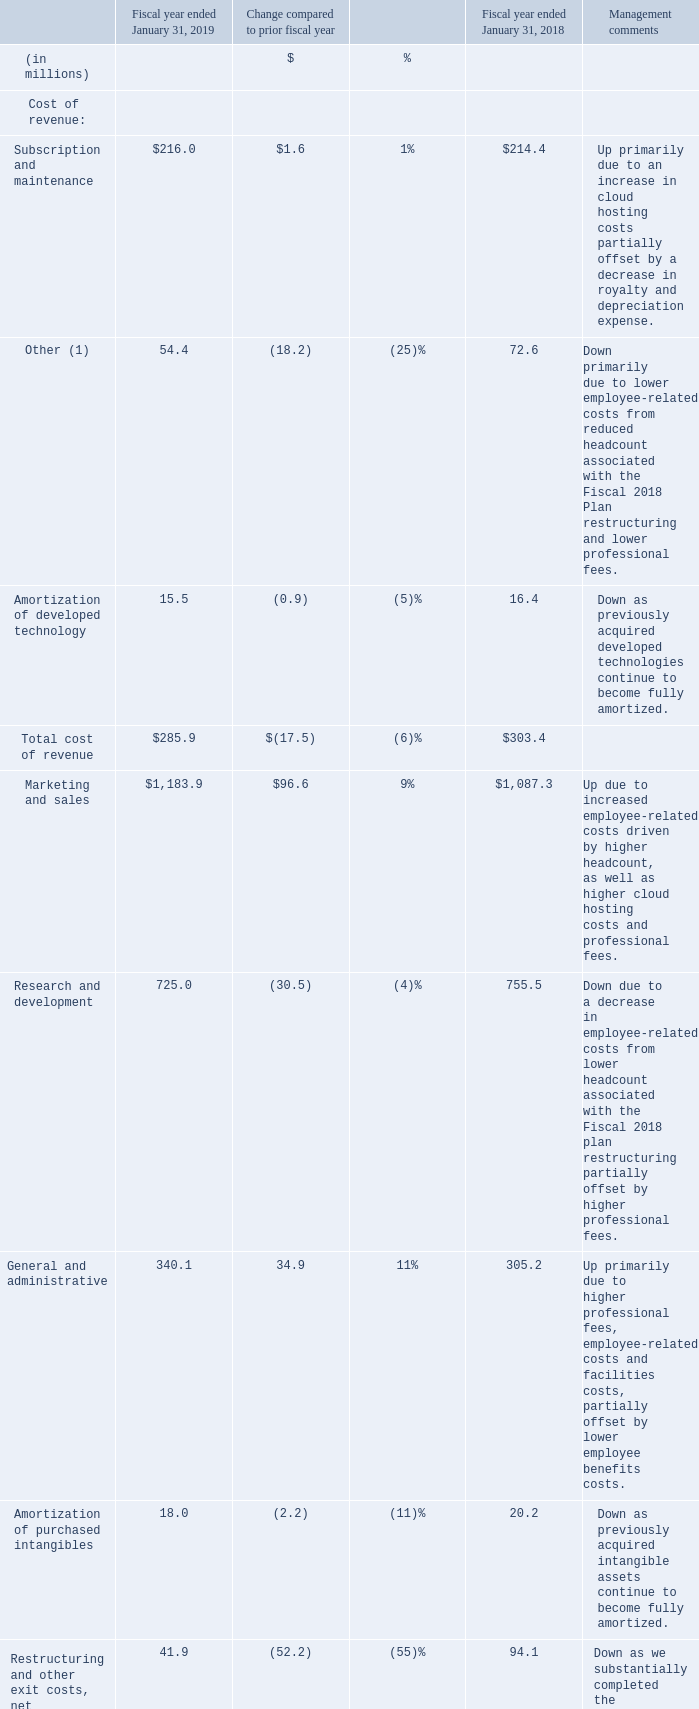Cost of Revenue and Operating Expenses
Cost of subscription and maintenance revenue includes the labor costs of providing product support to our subscription and maintenance customers, including allocated IT and facilities costs, professional services fees related to operating our network and cloud infrastructure, royalties, depreciation expense and operating lease payments associated with computer equipment, data center costs, salaries, related expenses of network operations, and stock-based compensation expense.
Cost of other revenue includes labor costs associated with product setup, costs of consulting and training services contracts, and collaborative project management services contracts. Cost of other revenue also includes stock-based compensation expense, direct material and overhead charges, allocated IT and facilities costs, professional services fees and royalties. Direct material and overhead charges include the cost associated with electronic and physical fulfillment.
Cost of revenue, at least over the near term, is affected by the volume and mix of product sales, fluctuations in consulting costs, amortization of developed technology, new customer support offerings, royalty rates for licensed technology embedded in our products and employee stock-based compensation expense
Marketing and sales expenses include salaries, bonuses, benefits and stock-based compensation expense for our marketing and sales employees, the expense of travel, entertainment and training for such personnel, sales and dealer commissions, and the costs of programs aimed at increasing revenue, such as advertising, trade shows and expositions, and various sales and promotional programs. Marketing and sales expenses also include payment processing fees, the cost of supplies and equipment, gains and losses on our operating expense cash flow hedges, allocated IT and facilities costs, and labor costs associated with sales and order management.
Research and development expenses, which are expensed as incurred, consist primarily of salaries, bonuses, benefits and stock-based compensation expense for research and development employees, the expense of travel, entertainment and training for such personnel, professional services such as fees paid to software development firms and independent contractors, gains and losses on our operating expense cash flow hedges, and allocated IT and facilities costs.
General and administrative expenses include salaries, bonuses, acquisition-related transition costs, benefits and stock-based compensation expense for our CEO, finance, human resources and legal employees, as well as professional fees for legal and accounting services, certain foreign business taxes, gains and losses on our operating expense cash flow hedges, expense of travel, entertainment and training, net IT and facilities costs, and the cost of supplies and equipment.
What are some of the marketing expenses incurred by the company? Salaries, bonuses, benefits and stock-based compensation expense for our marketing and sales employees, the expense of travel, entertainment and training for such personnel, sales and dealer commissions, and the costs of programs aimed at increasing revenue, such as advertising, trade shows and expositions, and various sales and promotional programs. What are some factors affecting cost of revenue in the near term? The volume and mix of product sales, fluctuations in consulting costs, amortization of developed technology, new customer support offerings, royalty rates for licensed technology embedded in our products and employee stock-based compensation expense. What is the total cost of revenue and operating expenses for fiscal year ended January 31, 2019?
Answer scale should be: million. 285.9 + 2,308.9 
Answer: 2594.8. How much do the top two expense categories in 2018 add up to? 
Answer scale should be: million. 1,087.3 + 755.5
Answer: 1842.8. How much does amortization of developed technology account for total cost of revenue in 2018?
Answer scale should be: percent. 15.5/285.9 
Answer: 5.42. What is the total cost of revenue for 2019?
Answer scale should be: million. 2,308.9. 